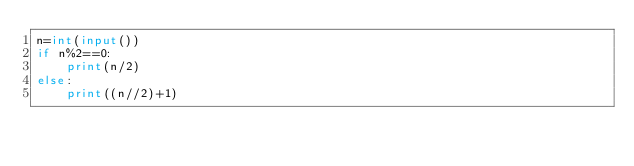<code> <loc_0><loc_0><loc_500><loc_500><_Python_>n=int(input())
if n%2==0:
    print(n/2)
else:
    print((n//2)+1)</code> 